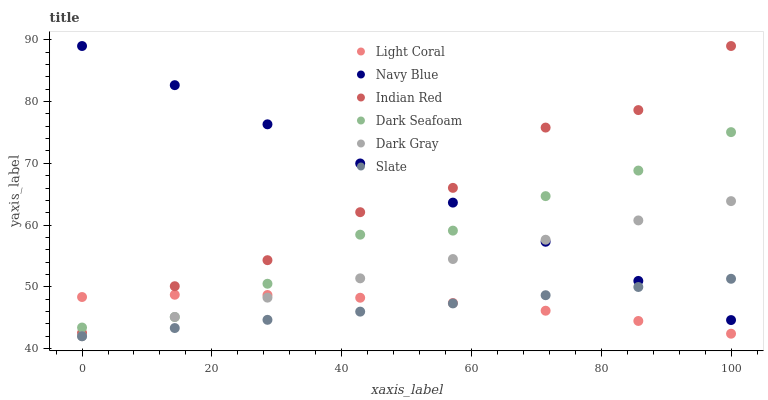Does Slate have the minimum area under the curve?
Answer yes or no. Yes. Does Navy Blue have the maximum area under the curve?
Answer yes or no. Yes. Does Navy Blue have the minimum area under the curve?
Answer yes or no. No. Does Slate have the maximum area under the curve?
Answer yes or no. No. Is Slate the smoothest?
Answer yes or no. Yes. Is Indian Red the roughest?
Answer yes or no. Yes. Is Navy Blue the smoothest?
Answer yes or no. No. Is Navy Blue the roughest?
Answer yes or no. No. Does Dark Gray have the lowest value?
Answer yes or no. Yes. Does Navy Blue have the lowest value?
Answer yes or no. No. Does Indian Red have the highest value?
Answer yes or no. Yes. Does Slate have the highest value?
Answer yes or no. No. Is Light Coral less than Navy Blue?
Answer yes or no. Yes. Is Dark Seafoam greater than Slate?
Answer yes or no. Yes. Does Light Coral intersect Dark Gray?
Answer yes or no. Yes. Is Light Coral less than Dark Gray?
Answer yes or no. No. Is Light Coral greater than Dark Gray?
Answer yes or no. No. Does Light Coral intersect Navy Blue?
Answer yes or no. No. 